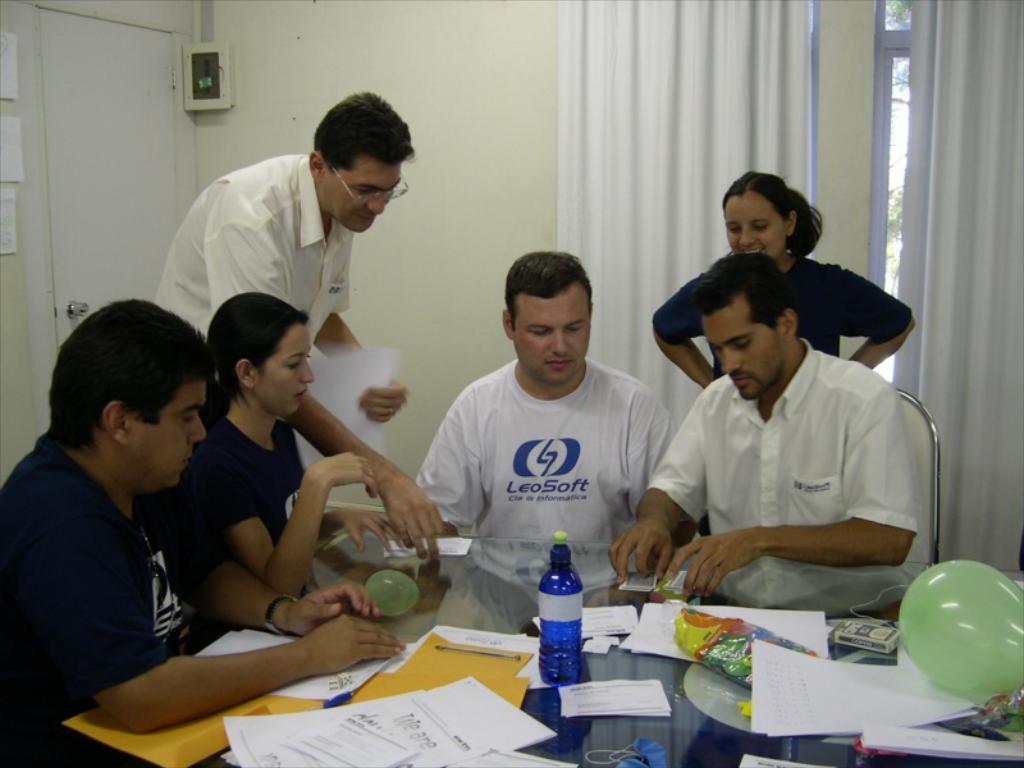How would you summarize this image in a sentence or two? In the picture I can see six persons. I can see four of them sitting on the chairs and two of them standing on the floor. I can see a man on the right side is wearing a shirt and he is holding the playing cards in his hands. I can see the glass table at the bottom of the picture. I can see the files, papers, a bottle and balloon are kept on the glass table. There is a door on the top left side of the picture. In the background, I can see the glass window and curtains. 